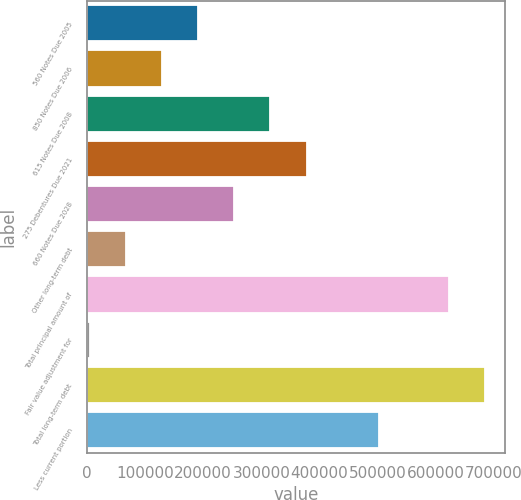Convert chart to OTSL. <chart><loc_0><loc_0><loc_500><loc_500><bar_chart><fcel>560 Notes Due 2005<fcel>850 Notes Due 2006<fcel>615 Notes Due 2008<fcel>275 Debentures Due 2021<fcel>660 Notes Due 2028<fcel>Other long-term debt<fcel>Total principal amount of<fcel>Fair value adjustment for<fcel>Total long-term debt<fcel>Less current portion<nl><fcel>191283<fcel>129064<fcel>315723<fcel>377943<fcel>253503<fcel>66843.8<fcel>622198<fcel>4624<fcel>684418<fcel>502382<nl></chart> 